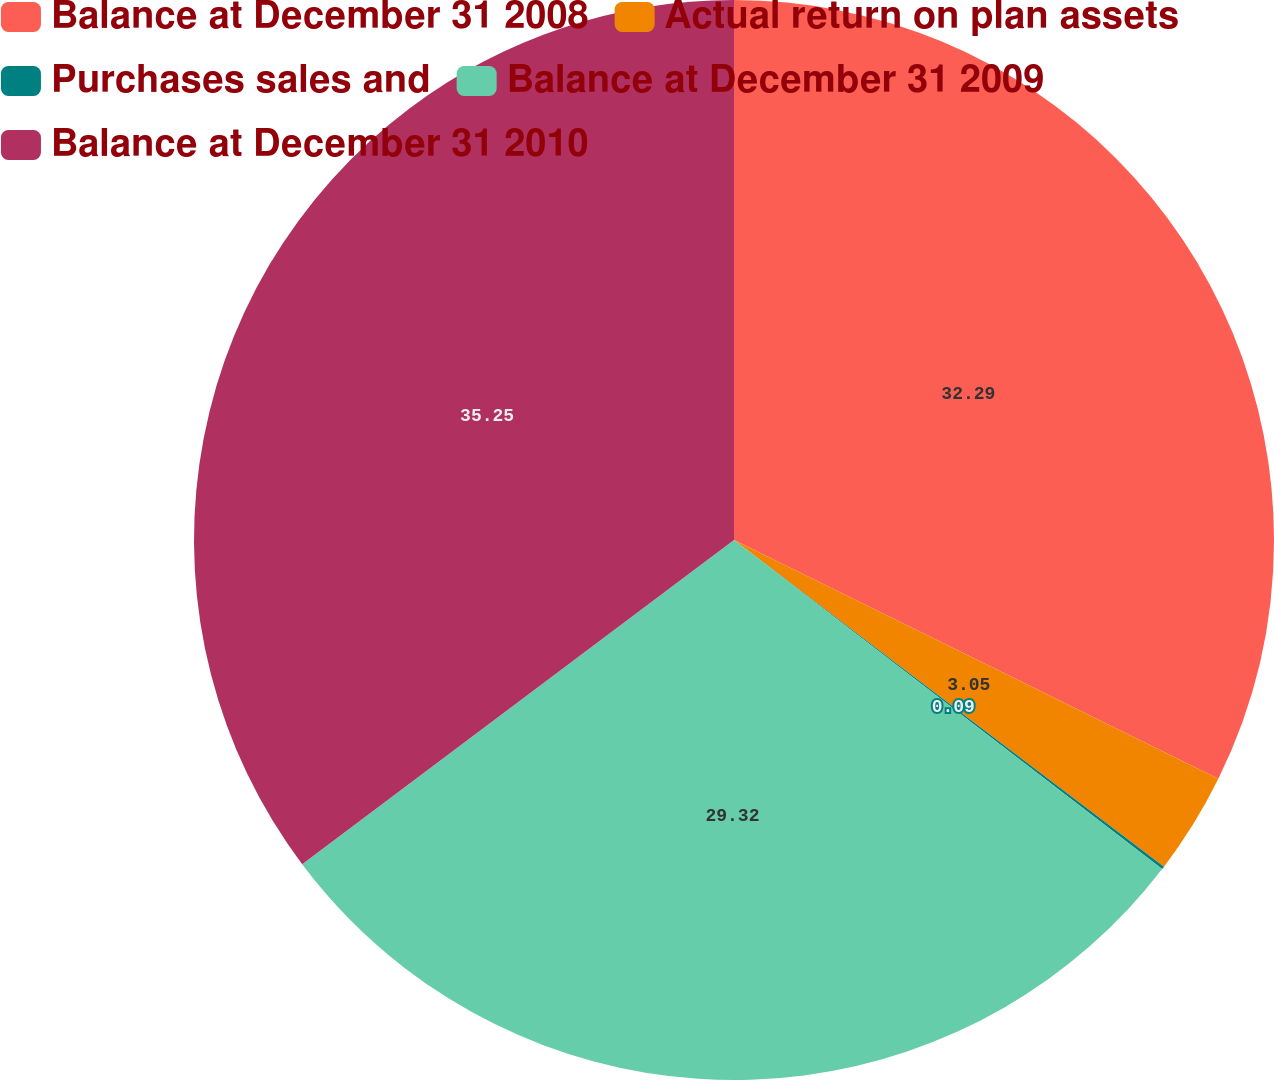Convert chart to OTSL. <chart><loc_0><loc_0><loc_500><loc_500><pie_chart><fcel>Balance at December 31 2008<fcel>Actual return on plan assets<fcel>Purchases sales and<fcel>Balance at December 31 2009<fcel>Balance at December 31 2010<nl><fcel>32.29%<fcel>3.05%<fcel>0.09%<fcel>29.32%<fcel>35.25%<nl></chart> 